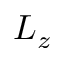<formula> <loc_0><loc_0><loc_500><loc_500>L _ { z }</formula> 